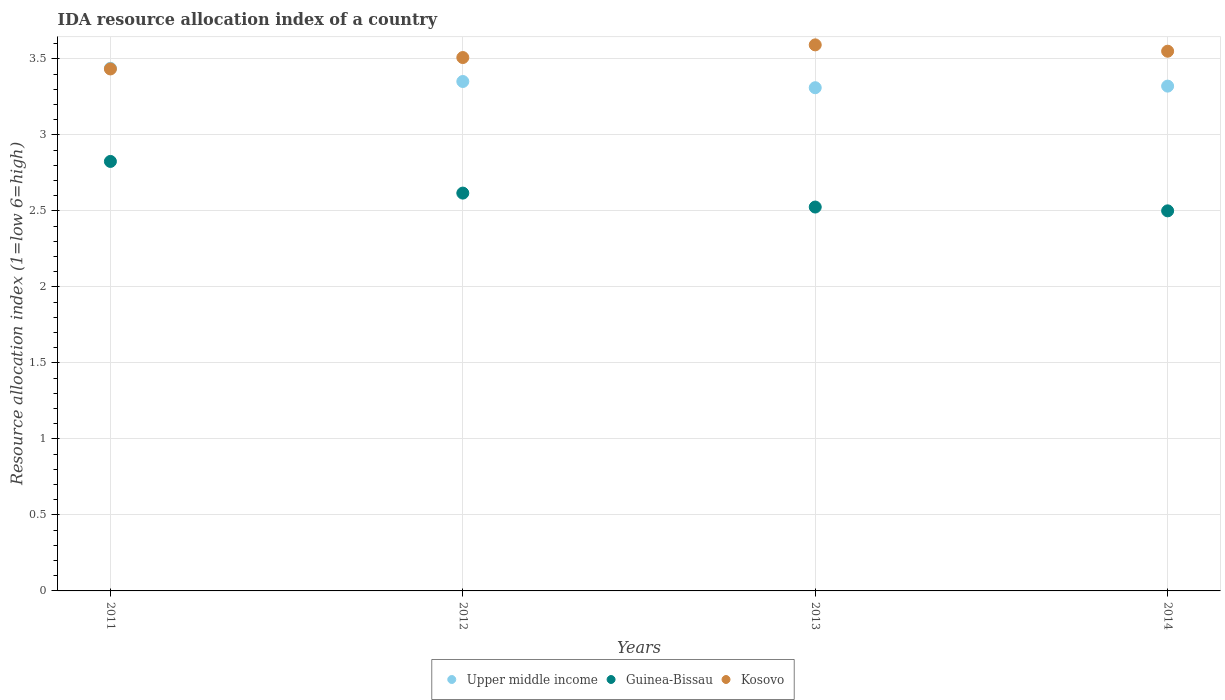How many different coloured dotlines are there?
Offer a terse response. 3. What is the IDA resource allocation index in Guinea-Bissau in 2013?
Offer a terse response. 2.52. Across all years, what is the maximum IDA resource allocation index in Kosovo?
Give a very brief answer. 3.59. Across all years, what is the minimum IDA resource allocation index in Kosovo?
Your answer should be very brief. 3.43. What is the total IDA resource allocation index in Guinea-Bissau in the graph?
Provide a short and direct response. 10.47. What is the difference between the IDA resource allocation index in Upper middle income in 2011 and that in 2014?
Offer a very short reply. 0.12. What is the difference between the IDA resource allocation index in Upper middle income in 2011 and the IDA resource allocation index in Guinea-Bissau in 2014?
Make the answer very short. 0.94. What is the average IDA resource allocation index in Upper middle income per year?
Your response must be concise. 3.35. In the year 2012, what is the difference between the IDA resource allocation index in Kosovo and IDA resource allocation index in Upper middle income?
Offer a very short reply. 0.16. What is the ratio of the IDA resource allocation index in Kosovo in 2012 to that in 2014?
Keep it short and to the point. 0.99. Is the IDA resource allocation index in Kosovo in 2013 less than that in 2014?
Your answer should be very brief. No. Is the difference between the IDA resource allocation index in Kosovo in 2012 and 2013 greater than the difference between the IDA resource allocation index in Upper middle income in 2012 and 2013?
Offer a very short reply. No. What is the difference between the highest and the second highest IDA resource allocation index in Upper middle income?
Your answer should be compact. 0.09. What is the difference between the highest and the lowest IDA resource allocation index in Kosovo?
Provide a short and direct response. 0.16. In how many years, is the IDA resource allocation index in Guinea-Bissau greater than the average IDA resource allocation index in Guinea-Bissau taken over all years?
Keep it short and to the point. 2. Is the sum of the IDA resource allocation index in Guinea-Bissau in 2012 and 2013 greater than the maximum IDA resource allocation index in Upper middle income across all years?
Your response must be concise. Yes. Does the IDA resource allocation index in Guinea-Bissau monotonically increase over the years?
Keep it short and to the point. No. Is the IDA resource allocation index in Upper middle income strictly greater than the IDA resource allocation index in Guinea-Bissau over the years?
Keep it short and to the point. Yes. How many dotlines are there?
Provide a succinct answer. 3. How many years are there in the graph?
Make the answer very short. 4. What is the difference between two consecutive major ticks on the Y-axis?
Give a very brief answer. 0.5. Where does the legend appear in the graph?
Your answer should be compact. Bottom center. How many legend labels are there?
Your response must be concise. 3. How are the legend labels stacked?
Offer a terse response. Horizontal. What is the title of the graph?
Your answer should be compact. IDA resource allocation index of a country. What is the label or title of the X-axis?
Ensure brevity in your answer.  Years. What is the label or title of the Y-axis?
Give a very brief answer. Resource allocation index (1=low 6=high). What is the Resource allocation index (1=low 6=high) in Upper middle income in 2011?
Make the answer very short. 3.44. What is the Resource allocation index (1=low 6=high) in Guinea-Bissau in 2011?
Provide a succinct answer. 2.83. What is the Resource allocation index (1=low 6=high) in Kosovo in 2011?
Provide a succinct answer. 3.43. What is the Resource allocation index (1=low 6=high) of Upper middle income in 2012?
Offer a very short reply. 3.35. What is the Resource allocation index (1=low 6=high) in Guinea-Bissau in 2012?
Ensure brevity in your answer.  2.62. What is the Resource allocation index (1=low 6=high) in Kosovo in 2012?
Make the answer very short. 3.51. What is the Resource allocation index (1=low 6=high) in Upper middle income in 2013?
Keep it short and to the point. 3.31. What is the Resource allocation index (1=low 6=high) in Guinea-Bissau in 2013?
Provide a succinct answer. 2.52. What is the Resource allocation index (1=low 6=high) in Kosovo in 2013?
Provide a succinct answer. 3.59. What is the Resource allocation index (1=low 6=high) of Upper middle income in 2014?
Keep it short and to the point. 3.32. What is the Resource allocation index (1=low 6=high) in Guinea-Bissau in 2014?
Keep it short and to the point. 2.5. What is the Resource allocation index (1=low 6=high) of Kosovo in 2014?
Offer a terse response. 3.55. Across all years, what is the maximum Resource allocation index (1=low 6=high) of Upper middle income?
Ensure brevity in your answer.  3.44. Across all years, what is the maximum Resource allocation index (1=low 6=high) in Guinea-Bissau?
Make the answer very short. 2.83. Across all years, what is the maximum Resource allocation index (1=low 6=high) of Kosovo?
Make the answer very short. 3.59. Across all years, what is the minimum Resource allocation index (1=low 6=high) of Upper middle income?
Give a very brief answer. 3.31. Across all years, what is the minimum Resource allocation index (1=low 6=high) in Guinea-Bissau?
Make the answer very short. 2.5. Across all years, what is the minimum Resource allocation index (1=low 6=high) in Kosovo?
Your answer should be compact. 3.43. What is the total Resource allocation index (1=low 6=high) in Upper middle income in the graph?
Provide a short and direct response. 13.42. What is the total Resource allocation index (1=low 6=high) of Guinea-Bissau in the graph?
Ensure brevity in your answer.  10.47. What is the total Resource allocation index (1=low 6=high) of Kosovo in the graph?
Offer a very short reply. 14.08. What is the difference between the Resource allocation index (1=low 6=high) of Upper middle income in 2011 and that in 2012?
Offer a terse response. 0.09. What is the difference between the Resource allocation index (1=low 6=high) in Guinea-Bissau in 2011 and that in 2012?
Ensure brevity in your answer.  0.21. What is the difference between the Resource allocation index (1=low 6=high) in Kosovo in 2011 and that in 2012?
Your response must be concise. -0.07. What is the difference between the Resource allocation index (1=low 6=high) of Upper middle income in 2011 and that in 2013?
Your answer should be very brief. 0.13. What is the difference between the Resource allocation index (1=low 6=high) of Kosovo in 2011 and that in 2013?
Provide a short and direct response. -0.16. What is the difference between the Resource allocation index (1=low 6=high) in Upper middle income in 2011 and that in 2014?
Give a very brief answer. 0.12. What is the difference between the Resource allocation index (1=low 6=high) in Guinea-Bissau in 2011 and that in 2014?
Your response must be concise. 0.33. What is the difference between the Resource allocation index (1=low 6=high) in Kosovo in 2011 and that in 2014?
Offer a terse response. -0.12. What is the difference between the Resource allocation index (1=low 6=high) in Upper middle income in 2012 and that in 2013?
Ensure brevity in your answer.  0.04. What is the difference between the Resource allocation index (1=low 6=high) of Guinea-Bissau in 2012 and that in 2013?
Give a very brief answer. 0.09. What is the difference between the Resource allocation index (1=low 6=high) in Kosovo in 2012 and that in 2013?
Provide a short and direct response. -0.08. What is the difference between the Resource allocation index (1=low 6=high) in Upper middle income in 2012 and that in 2014?
Your answer should be compact. 0.03. What is the difference between the Resource allocation index (1=low 6=high) of Guinea-Bissau in 2012 and that in 2014?
Offer a very short reply. 0.12. What is the difference between the Resource allocation index (1=low 6=high) of Kosovo in 2012 and that in 2014?
Make the answer very short. -0.04. What is the difference between the Resource allocation index (1=low 6=high) of Upper middle income in 2013 and that in 2014?
Keep it short and to the point. -0.01. What is the difference between the Resource allocation index (1=low 6=high) of Guinea-Bissau in 2013 and that in 2014?
Your response must be concise. 0.03. What is the difference between the Resource allocation index (1=low 6=high) of Kosovo in 2013 and that in 2014?
Keep it short and to the point. 0.04. What is the difference between the Resource allocation index (1=low 6=high) in Upper middle income in 2011 and the Resource allocation index (1=low 6=high) in Guinea-Bissau in 2012?
Make the answer very short. 0.82. What is the difference between the Resource allocation index (1=low 6=high) in Upper middle income in 2011 and the Resource allocation index (1=low 6=high) in Kosovo in 2012?
Ensure brevity in your answer.  -0.07. What is the difference between the Resource allocation index (1=low 6=high) of Guinea-Bissau in 2011 and the Resource allocation index (1=low 6=high) of Kosovo in 2012?
Provide a short and direct response. -0.68. What is the difference between the Resource allocation index (1=low 6=high) in Upper middle income in 2011 and the Resource allocation index (1=low 6=high) in Guinea-Bissau in 2013?
Give a very brief answer. 0.91. What is the difference between the Resource allocation index (1=low 6=high) in Upper middle income in 2011 and the Resource allocation index (1=low 6=high) in Kosovo in 2013?
Ensure brevity in your answer.  -0.15. What is the difference between the Resource allocation index (1=low 6=high) in Guinea-Bissau in 2011 and the Resource allocation index (1=low 6=high) in Kosovo in 2013?
Provide a succinct answer. -0.77. What is the difference between the Resource allocation index (1=low 6=high) of Upper middle income in 2011 and the Resource allocation index (1=low 6=high) of Kosovo in 2014?
Keep it short and to the point. -0.11. What is the difference between the Resource allocation index (1=low 6=high) of Guinea-Bissau in 2011 and the Resource allocation index (1=low 6=high) of Kosovo in 2014?
Provide a short and direct response. -0.72. What is the difference between the Resource allocation index (1=low 6=high) in Upper middle income in 2012 and the Resource allocation index (1=low 6=high) in Guinea-Bissau in 2013?
Provide a short and direct response. 0.83. What is the difference between the Resource allocation index (1=low 6=high) in Upper middle income in 2012 and the Resource allocation index (1=low 6=high) in Kosovo in 2013?
Your answer should be compact. -0.24. What is the difference between the Resource allocation index (1=low 6=high) in Guinea-Bissau in 2012 and the Resource allocation index (1=low 6=high) in Kosovo in 2013?
Give a very brief answer. -0.97. What is the difference between the Resource allocation index (1=low 6=high) in Upper middle income in 2012 and the Resource allocation index (1=low 6=high) in Guinea-Bissau in 2014?
Offer a terse response. 0.85. What is the difference between the Resource allocation index (1=low 6=high) in Upper middle income in 2012 and the Resource allocation index (1=low 6=high) in Kosovo in 2014?
Make the answer very short. -0.2. What is the difference between the Resource allocation index (1=low 6=high) of Guinea-Bissau in 2012 and the Resource allocation index (1=low 6=high) of Kosovo in 2014?
Ensure brevity in your answer.  -0.93. What is the difference between the Resource allocation index (1=low 6=high) in Upper middle income in 2013 and the Resource allocation index (1=low 6=high) in Guinea-Bissau in 2014?
Your response must be concise. 0.81. What is the difference between the Resource allocation index (1=low 6=high) in Upper middle income in 2013 and the Resource allocation index (1=low 6=high) in Kosovo in 2014?
Offer a terse response. -0.24. What is the difference between the Resource allocation index (1=low 6=high) of Guinea-Bissau in 2013 and the Resource allocation index (1=low 6=high) of Kosovo in 2014?
Your answer should be very brief. -1.02. What is the average Resource allocation index (1=low 6=high) of Upper middle income per year?
Provide a succinct answer. 3.35. What is the average Resource allocation index (1=low 6=high) of Guinea-Bissau per year?
Ensure brevity in your answer.  2.62. What is the average Resource allocation index (1=low 6=high) in Kosovo per year?
Offer a terse response. 3.52. In the year 2011, what is the difference between the Resource allocation index (1=low 6=high) of Upper middle income and Resource allocation index (1=low 6=high) of Guinea-Bissau?
Offer a very short reply. 0.61. In the year 2011, what is the difference between the Resource allocation index (1=low 6=high) in Upper middle income and Resource allocation index (1=low 6=high) in Kosovo?
Offer a terse response. 0. In the year 2011, what is the difference between the Resource allocation index (1=low 6=high) in Guinea-Bissau and Resource allocation index (1=low 6=high) in Kosovo?
Provide a short and direct response. -0.61. In the year 2012, what is the difference between the Resource allocation index (1=low 6=high) of Upper middle income and Resource allocation index (1=low 6=high) of Guinea-Bissau?
Your answer should be very brief. 0.73. In the year 2012, what is the difference between the Resource allocation index (1=low 6=high) of Upper middle income and Resource allocation index (1=low 6=high) of Kosovo?
Provide a short and direct response. -0.16. In the year 2012, what is the difference between the Resource allocation index (1=low 6=high) of Guinea-Bissau and Resource allocation index (1=low 6=high) of Kosovo?
Keep it short and to the point. -0.89. In the year 2013, what is the difference between the Resource allocation index (1=low 6=high) of Upper middle income and Resource allocation index (1=low 6=high) of Guinea-Bissau?
Offer a very short reply. 0.78. In the year 2013, what is the difference between the Resource allocation index (1=low 6=high) of Upper middle income and Resource allocation index (1=low 6=high) of Kosovo?
Make the answer very short. -0.28. In the year 2013, what is the difference between the Resource allocation index (1=low 6=high) of Guinea-Bissau and Resource allocation index (1=low 6=high) of Kosovo?
Your answer should be very brief. -1.07. In the year 2014, what is the difference between the Resource allocation index (1=low 6=high) of Upper middle income and Resource allocation index (1=low 6=high) of Guinea-Bissau?
Offer a very short reply. 0.82. In the year 2014, what is the difference between the Resource allocation index (1=low 6=high) of Upper middle income and Resource allocation index (1=low 6=high) of Kosovo?
Give a very brief answer. -0.23. In the year 2014, what is the difference between the Resource allocation index (1=low 6=high) in Guinea-Bissau and Resource allocation index (1=low 6=high) in Kosovo?
Your answer should be very brief. -1.05. What is the ratio of the Resource allocation index (1=low 6=high) in Upper middle income in 2011 to that in 2012?
Ensure brevity in your answer.  1.03. What is the ratio of the Resource allocation index (1=low 6=high) of Guinea-Bissau in 2011 to that in 2012?
Offer a very short reply. 1.08. What is the ratio of the Resource allocation index (1=low 6=high) in Kosovo in 2011 to that in 2012?
Make the answer very short. 0.98. What is the ratio of the Resource allocation index (1=low 6=high) of Upper middle income in 2011 to that in 2013?
Give a very brief answer. 1.04. What is the ratio of the Resource allocation index (1=low 6=high) in Guinea-Bissau in 2011 to that in 2013?
Your answer should be compact. 1.12. What is the ratio of the Resource allocation index (1=low 6=high) of Kosovo in 2011 to that in 2013?
Your answer should be compact. 0.96. What is the ratio of the Resource allocation index (1=low 6=high) in Upper middle income in 2011 to that in 2014?
Your answer should be very brief. 1.04. What is the ratio of the Resource allocation index (1=low 6=high) in Guinea-Bissau in 2011 to that in 2014?
Give a very brief answer. 1.13. What is the ratio of the Resource allocation index (1=low 6=high) in Kosovo in 2011 to that in 2014?
Offer a very short reply. 0.97. What is the ratio of the Resource allocation index (1=low 6=high) in Upper middle income in 2012 to that in 2013?
Offer a very short reply. 1.01. What is the ratio of the Resource allocation index (1=low 6=high) in Guinea-Bissau in 2012 to that in 2013?
Your answer should be very brief. 1.04. What is the ratio of the Resource allocation index (1=low 6=high) of Kosovo in 2012 to that in 2013?
Ensure brevity in your answer.  0.98. What is the ratio of the Resource allocation index (1=low 6=high) in Upper middle income in 2012 to that in 2014?
Offer a terse response. 1.01. What is the ratio of the Resource allocation index (1=low 6=high) in Guinea-Bissau in 2012 to that in 2014?
Your answer should be compact. 1.05. What is the ratio of the Resource allocation index (1=low 6=high) in Kosovo in 2012 to that in 2014?
Your answer should be compact. 0.99. What is the ratio of the Resource allocation index (1=low 6=high) in Kosovo in 2013 to that in 2014?
Ensure brevity in your answer.  1.01. What is the difference between the highest and the second highest Resource allocation index (1=low 6=high) of Upper middle income?
Your response must be concise. 0.09. What is the difference between the highest and the second highest Resource allocation index (1=low 6=high) in Guinea-Bissau?
Your answer should be compact. 0.21. What is the difference between the highest and the second highest Resource allocation index (1=low 6=high) in Kosovo?
Your response must be concise. 0.04. What is the difference between the highest and the lowest Resource allocation index (1=low 6=high) of Upper middle income?
Offer a terse response. 0.13. What is the difference between the highest and the lowest Resource allocation index (1=low 6=high) in Guinea-Bissau?
Make the answer very short. 0.33. What is the difference between the highest and the lowest Resource allocation index (1=low 6=high) in Kosovo?
Your response must be concise. 0.16. 